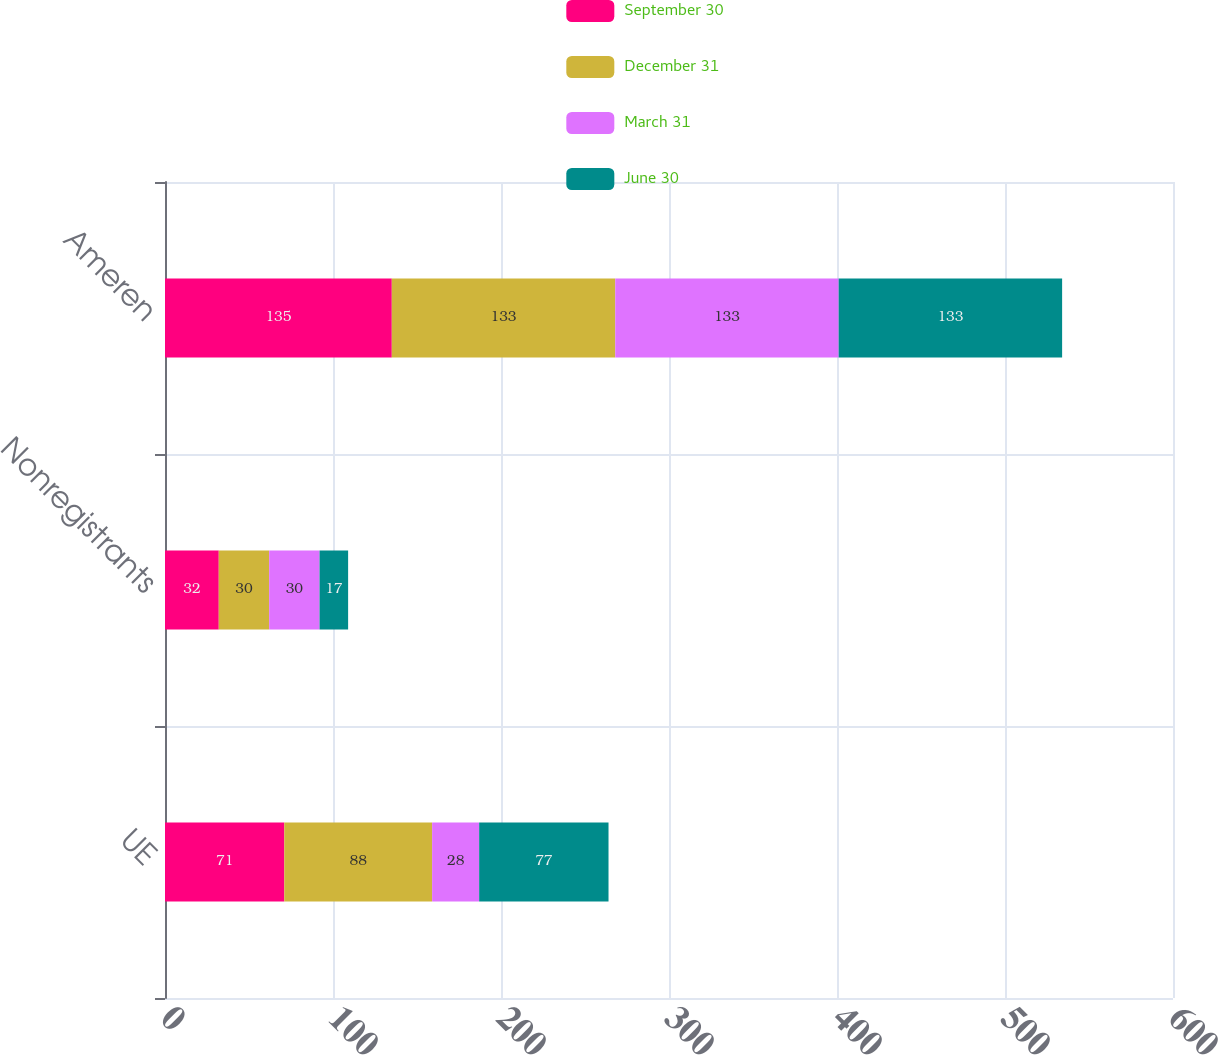<chart> <loc_0><loc_0><loc_500><loc_500><stacked_bar_chart><ecel><fcel>UE<fcel>Nonregistrants<fcel>Ameren<nl><fcel>September 30<fcel>71<fcel>32<fcel>135<nl><fcel>December 31<fcel>88<fcel>30<fcel>133<nl><fcel>March 31<fcel>28<fcel>30<fcel>133<nl><fcel>June 30<fcel>77<fcel>17<fcel>133<nl></chart> 